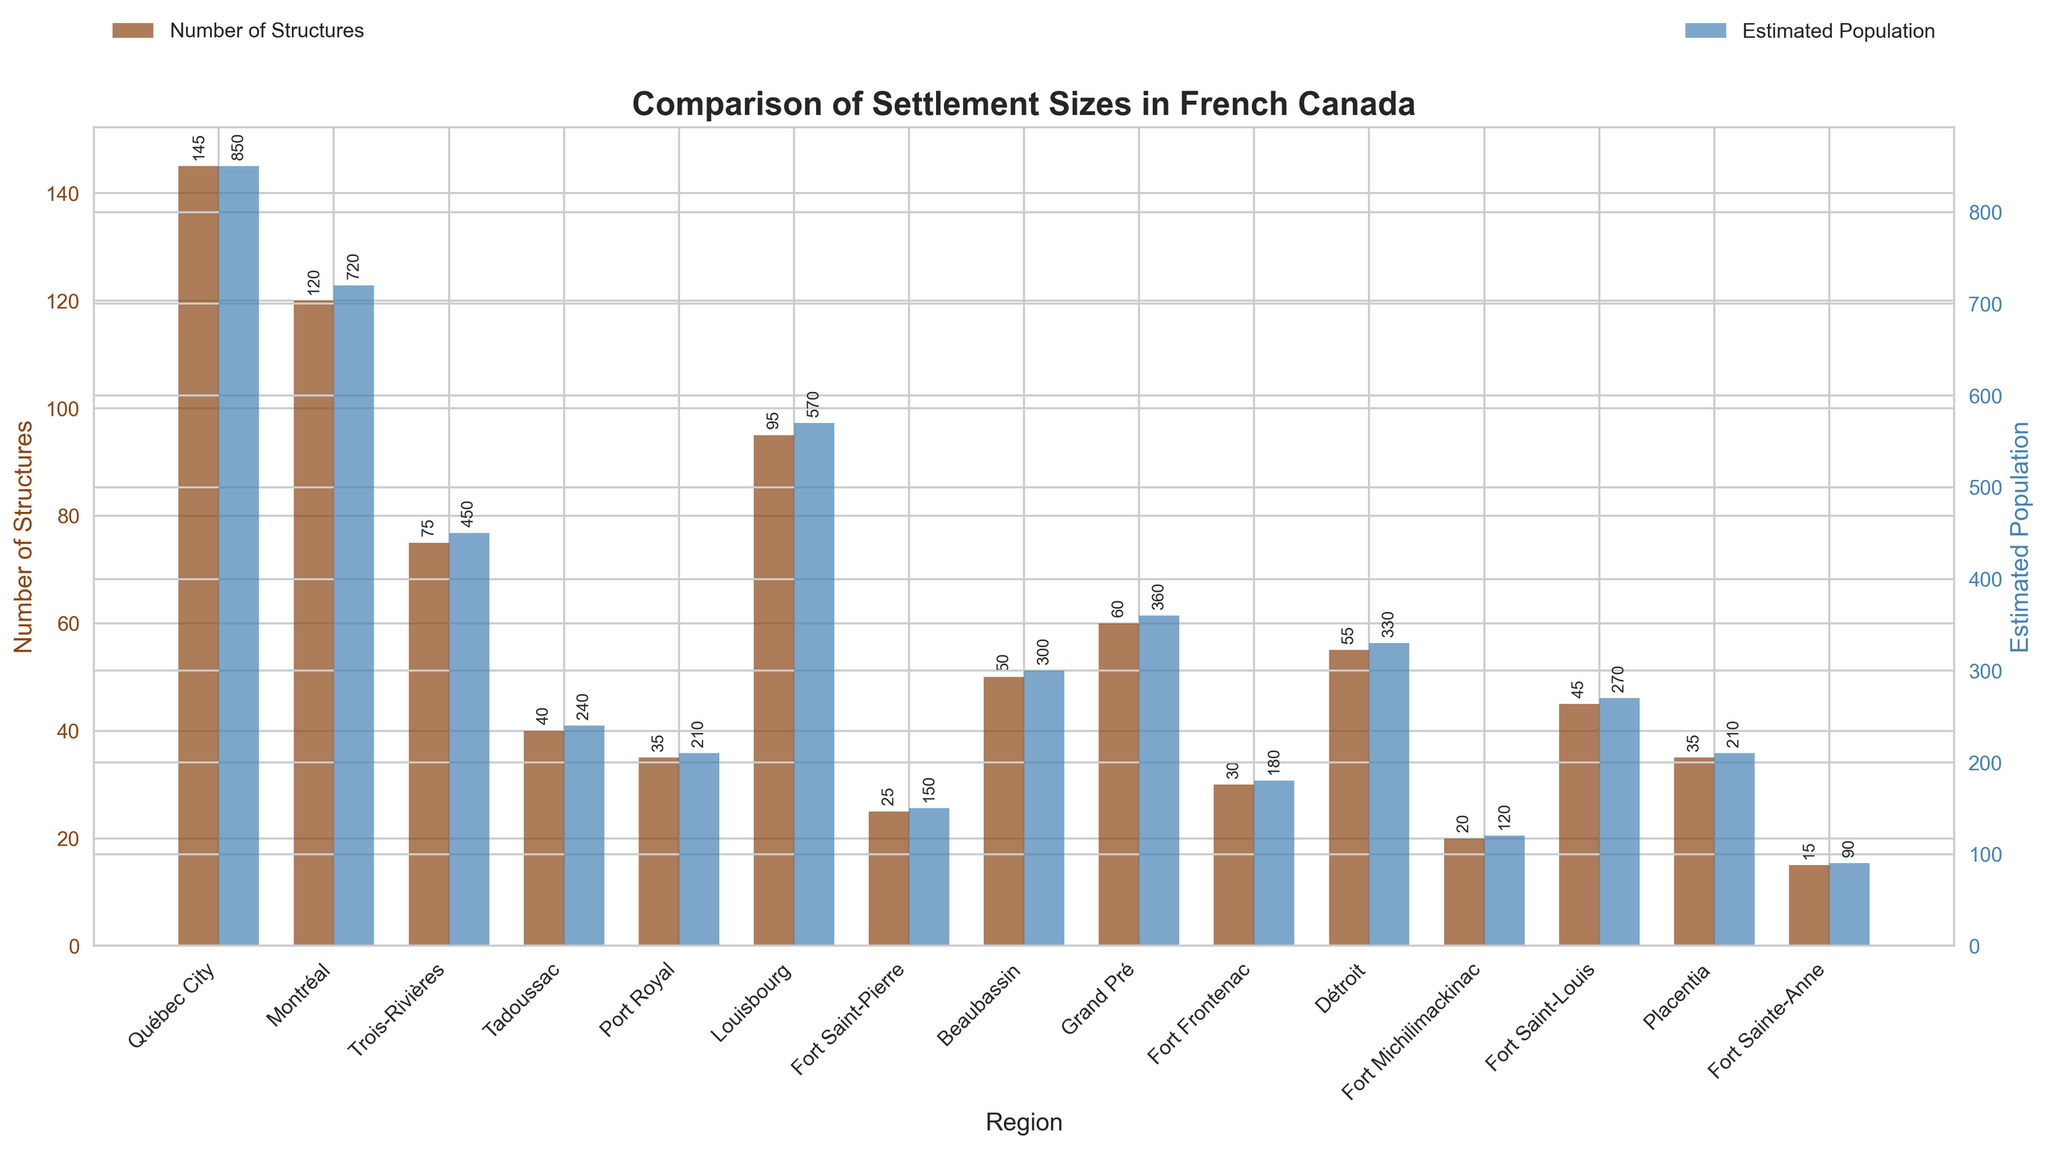What's the region with the highest estimated population? The tallest bar on the "Estimated Population" side is the blue bar representing Québec City with an estimated population of 850.
Answer: Québec City Which region has more structures, Montréal or Trois-Rivières? The brown bar representing structures in Montréal is taller than the corresponding bar for Trois-Rivières, with 120 structures against 75 in Trois-Rivières.
Answer: Montréal What is the total estimated population for all regions together? Sum the heights of all the blue bars representing the estimated populations for each region: 850 + 720 + 450 + 240 + 210 + 570 + 150 + 300 + 360 + 180 + 330 + 120 + 270 + 210 + 90 = 5050.
Answer: 5050 Which two regions have the closest estimated populations? Comparing the heights of the blue bars, Port Royal and Placentia have the same estimated population of 210, making them the closest in value.
Answer: Port Royal and Placentia What's the average number of structures across all regions? Sum the number of structures for all regions and then divide by the number of regions: (145 + 120 + 75 + 40 + 35 + 95 + 25 + 50 + 60 + 30 + 55 + 20 + 45 + 35 + 15) / 15 = 845 / 15 = 56.33.
Answer: 56.33 In which region is the difference between the number of structures and estimated population the greatest? Subtract the number of structures from the estimated population for each region and find the maximum difference: Québec City (850 - 145 = 705), Montréal (720 - 120 = 600), ..., Fort Sainte-Anne (90 - 15 = 75). The greatest difference is in Québec City with 705.
Answer: Québec City How many regions have an estimated population less than 300? Count the regions with a blue bar height representing an estimated population less than 300: Tadoussac, Port Royal, Fort Saint-Pierre, Fort Frontenac, Fort Michilimackinac, Fort Saint-Louis, Placentia, Fort Sainte-Anne. There are 8 regions.
Answer: 8 Which regions have both the number of structures and estimated population exactly equal? Comparing both bars precisely, none of the regions have both the same number of structures and estimated populations.
Answer: None What is the ratio of estimated population to the number of structures in Grand Pré? Divide the estimated population by the number of structures for Grand Pré: 360 / 60 = 6.
Answer: 6 Which region has the lowest number of structures and what is the corresponding estimated population? The shortest brown bar indicating the lowest number of structures (15) is for Fort Sainte-Anne, which has an estimated population of 90.
Answer: Fort Sainte-Anne, 90 